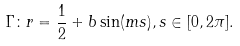<formula> <loc_0><loc_0><loc_500><loc_500>\Gamma \colon r = \frac { 1 } { 2 } + b \sin ( m s ) , s \in [ 0 , 2 \pi ] .</formula> 